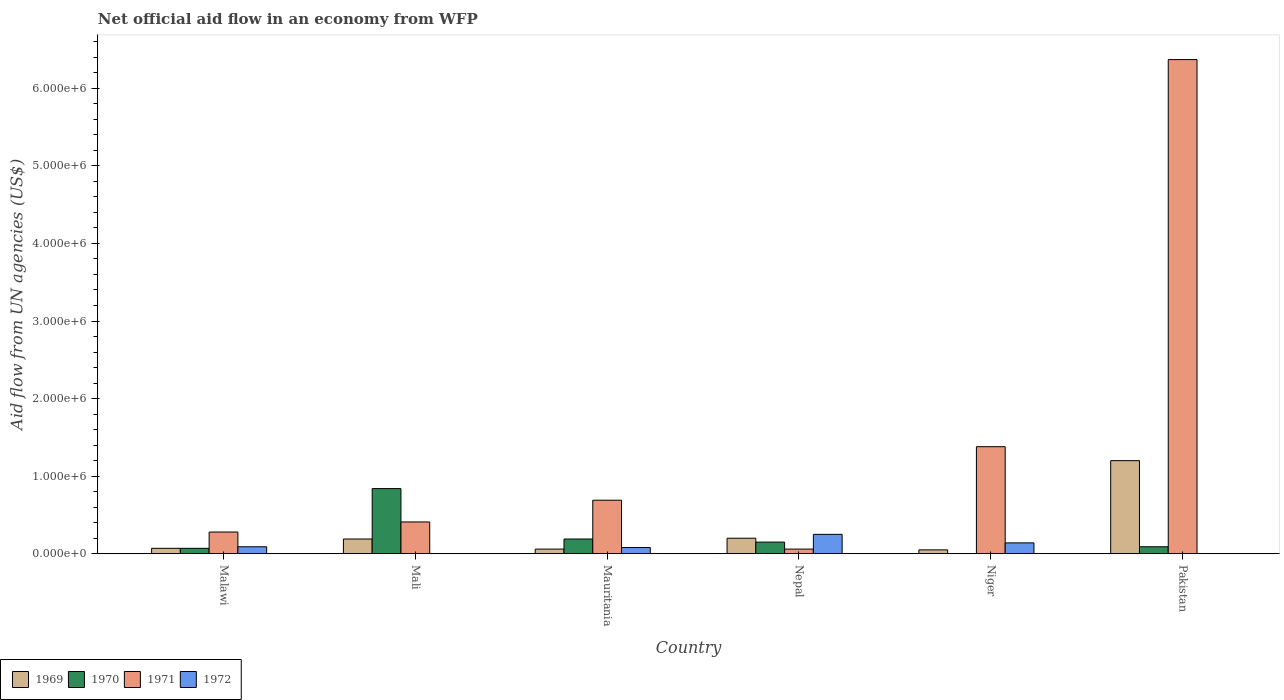How many different coloured bars are there?
Provide a short and direct response. 4. Are the number of bars per tick equal to the number of legend labels?
Provide a short and direct response. No. How many bars are there on the 6th tick from the left?
Provide a short and direct response. 3. How many bars are there on the 3rd tick from the right?
Ensure brevity in your answer.  4. What is the label of the 4th group of bars from the left?
Your response must be concise. Nepal. In how many cases, is the number of bars for a given country not equal to the number of legend labels?
Ensure brevity in your answer.  3. Across all countries, what is the maximum net official aid flow in 1971?
Your answer should be compact. 6.37e+06. Across all countries, what is the minimum net official aid flow in 1969?
Make the answer very short. 5.00e+04. In which country was the net official aid flow in 1970 maximum?
Your answer should be very brief. Mali. What is the total net official aid flow in 1969 in the graph?
Give a very brief answer. 1.77e+06. What is the difference between the net official aid flow in 1971 in Mali and that in Nepal?
Make the answer very short. 3.50e+05. What is the difference between the net official aid flow in 1969 in Pakistan and the net official aid flow in 1971 in Niger?
Your response must be concise. -1.80e+05. What is the average net official aid flow in 1970 per country?
Offer a terse response. 2.23e+05. What is the ratio of the net official aid flow in 1972 in Nepal to that in Niger?
Offer a terse response. 1.79. What is the difference between the highest and the second highest net official aid flow in 1971?
Offer a terse response. 5.68e+06. What is the difference between the highest and the lowest net official aid flow in 1971?
Your response must be concise. 6.31e+06. In how many countries, is the net official aid flow in 1969 greater than the average net official aid flow in 1969 taken over all countries?
Your response must be concise. 1. Is the sum of the net official aid flow in 1969 in Malawi and Mauritania greater than the maximum net official aid flow in 1970 across all countries?
Your answer should be compact. No. Is it the case that in every country, the sum of the net official aid flow in 1970 and net official aid flow in 1971 is greater than the net official aid flow in 1969?
Make the answer very short. Yes. Are all the bars in the graph horizontal?
Your answer should be very brief. No. How many countries are there in the graph?
Keep it short and to the point. 6. What is the difference between two consecutive major ticks on the Y-axis?
Provide a short and direct response. 1.00e+06. Are the values on the major ticks of Y-axis written in scientific E-notation?
Your response must be concise. Yes. Does the graph contain grids?
Your answer should be compact. No. Where does the legend appear in the graph?
Offer a terse response. Bottom left. How many legend labels are there?
Your answer should be very brief. 4. What is the title of the graph?
Offer a very short reply. Net official aid flow in an economy from WFP. What is the label or title of the Y-axis?
Offer a terse response. Aid flow from UN agencies (US$). What is the Aid flow from UN agencies (US$) of 1969 in Malawi?
Offer a very short reply. 7.00e+04. What is the Aid flow from UN agencies (US$) of 1970 in Malawi?
Offer a terse response. 7.00e+04. What is the Aid flow from UN agencies (US$) of 1970 in Mali?
Your answer should be compact. 8.40e+05. What is the Aid flow from UN agencies (US$) in 1971 in Mali?
Provide a succinct answer. 4.10e+05. What is the Aid flow from UN agencies (US$) of 1969 in Mauritania?
Provide a short and direct response. 6.00e+04. What is the Aid flow from UN agencies (US$) of 1971 in Mauritania?
Keep it short and to the point. 6.90e+05. What is the Aid flow from UN agencies (US$) in 1972 in Mauritania?
Keep it short and to the point. 8.00e+04. What is the Aid flow from UN agencies (US$) of 1969 in Nepal?
Offer a terse response. 2.00e+05. What is the Aid flow from UN agencies (US$) in 1970 in Nepal?
Provide a succinct answer. 1.50e+05. What is the Aid flow from UN agencies (US$) in 1969 in Niger?
Give a very brief answer. 5.00e+04. What is the Aid flow from UN agencies (US$) of 1970 in Niger?
Give a very brief answer. 0. What is the Aid flow from UN agencies (US$) in 1971 in Niger?
Your answer should be very brief. 1.38e+06. What is the Aid flow from UN agencies (US$) of 1969 in Pakistan?
Your response must be concise. 1.20e+06. What is the Aid flow from UN agencies (US$) of 1971 in Pakistan?
Make the answer very short. 6.37e+06. What is the Aid flow from UN agencies (US$) in 1972 in Pakistan?
Provide a short and direct response. 0. Across all countries, what is the maximum Aid flow from UN agencies (US$) in 1969?
Your answer should be very brief. 1.20e+06. Across all countries, what is the maximum Aid flow from UN agencies (US$) of 1970?
Make the answer very short. 8.40e+05. Across all countries, what is the maximum Aid flow from UN agencies (US$) in 1971?
Your answer should be compact. 6.37e+06. Across all countries, what is the minimum Aid flow from UN agencies (US$) in 1970?
Offer a very short reply. 0. Across all countries, what is the minimum Aid flow from UN agencies (US$) of 1972?
Ensure brevity in your answer.  0. What is the total Aid flow from UN agencies (US$) in 1969 in the graph?
Give a very brief answer. 1.77e+06. What is the total Aid flow from UN agencies (US$) of 1970 in the graph?
Offer a terse response. 1.34e+06. What is the total Aid flow from UN agencies (US$) of 1971 in the graph?
Make the answer very short. 9.19e+06. What is the total Aid flow from UN agencies (US$) of 1972 in the graph?
Make the answer very short. 5.60e+05. What is the difference between the Aid flow from UN agencies (US$) of 1969 in Malawi and that in Mali?
Offer a terse response. -1.20e+05. What is the difference between the Aid flow from UN agencies (US$) of 1970 in Malawi and that in Mali?
Make the answer very short. -7.70e+05. What is the difference between the Aid flow from UN agencies (US$) of 1971 in Malawi and that in Mali?
Offer a very short reply. -1.30e+05. What is the difference between the Aid flow from UN agencies (US$) of 1969 in Malawi and that in Mauritania?
Provide a short and direct response. 10000. What is the difference between the Aid flow from UN agencies (US$) of 1971 in Malawi and that in Mauritania?
Provide a succinct answer. -4.10e+05. What is the difference between the Aid flow from UN agencies (US$) of 1972 in Malawi and that in Mauritania?
Give a very brief answer. 10000. What is the difference between the Aid flow from UN agencies (US$) of 1971 in Malawi and that in Niger?
Provide a short and direct response. -1.10e+06. What is the difference between the Aid flow from UN agencies (US$) of 1972 in Malawi and that in Niger?
Keep it short and to the point. -5.00e+04. What is the difference between the Aid flow from UN agencies (US$) in 1969 in Malawi and that in Pakistan?
Your answer should be compact. -1.13e+06. What is the difference between the Aid flow from UN agencies (US$) in 1971 in Malawi and that in Pakistan?
Make the answer very short. -6.09e+06. What is the difference between the Aid flow from UN agencies (US$) of 1969 in Mali and that in Mauritania?
Your answer should be very brief. 1.30e+05. What is the difference between the Aid flow from UN agencies (US$) of 1970 in Mali and that in Mauritania?
Offer a very short reply. 6.50e+05. What is the difference between the Aid flow from UN agencies (US$) of 1971 in Mali and that in Mauritania?
Keep it short and to the point. -2.80e+05. What is the difference between the Aid flow from UN agencies (US$) of 1970 in Mali and that in Nepal?
Give a very brief answer. 6.90e+05. What is the difference between the Aid flow from UN agencies (US$) of 1971 in Mali and that in Nepal?
Provide a short and direct response. 3.50e+05. What is the difference between the Aid flow from UN agencies (US$) of 1969 in Mali and that in Niger?
Provide a short and direct response. 1.40e+05. What is the difference between the Aid flow from UN agencies (US$) of 1971 in Mali and that in Niger?
Provide a short and direct response. -9.70e+05. What is the difference between the Aid flow from UN agencies (US$) of 1969 in Mali and that in Pakistan?
Your answer should be compact. -1.01e+06. What is the difference between the Aid flow from UN agencies (US$) of 1970 in Mali and that in Pakistan?
Keep it short and to the point. 7.50e+05. What is the difference between the Aid flow from UN agencies (US$) in 1971 in Mali and that in Pakistan?
Your answer should be very brief. -5.96e+06. What is the difference between the Aid flow from UN agencies (US$) of 1969 in Mauritania and that in Nepal?
Your answer should be very brief. -1.40e+05. What is the difference between the Aid flow from UN agencies (US$) of 1970 in Mauritania and that in Nepal?
Offer a terse response. 4.00e+04. What is the difference between the Aid flow from UN agencies (US$) in 1971 in Mauritania and that in Nepal?
Your answer should be compact. 6.30e+05. What is the difference between the Aid flow from UN agencies (US$) of 1972 in Mauritania and that in Nepal?
Offer a terse response. -1.70e+05. What is the difference between the Aid flow from UN agencies (US$) in 1969 in Mauritania and that in Niger?
Your response must be concise. 10000. What is the difference between the Aid flow from UN agencies (US$) of 1971 in Mauritania and that in Niger?
Make the answer very short. -6.90e+05. What is the difference between the Aid flow from UN agencies (US$) in 1969 in Mauritania and that in Pakistan?
Your answer should be very brief. -1.14e+06. What is the difference between the Aid flow from UN agencies (US$) in 1970 in Mauritania and that in Pakistan?
Give a very brief answer. 1.00e+05. What is the difference between the Aid flow from UN agencies (US$) of 1971 in Mauritania and that in Pakistan?
Your response must be concise. -5.68e+06. What is the difference between the Aid flow from UN agencies (US$) in 1971 in Nepal and that in Niger?
Your answer should be very brief. -1.32e+06. What is the difference between the Aid flow from UN agencies (US$) of 1972 in Nepal and that in Niger?
Provide a succinct answer. 1.10e+05. What is the difference between the Aid flow from UN agencies (US$) in 1969 in Nepal and that in Pakistan?
Your answer should be very brief. -1.00e+06. What is the difference between the Aid flow from UN agencies (US$) in 1971 in Nepal and that in Pakistan?
Offer a very short reply. -6.31e+06. What is the difference between the Aid flow from UN agencies (US$) in 1969 in Niger and that in Pakistan?
Offer a terse response. -1.15e+06. What is the difference between the Aid flow from UN agencies (US$) of 1971 in Niger and that in Pakistan?
Offer a very short reply. -4.99e+06. What is the difference between the Aid flow from UN agencies (US$) in 1969 in Malawi and the Aid flow from UN agencies (US$) in 1970 in Mali?
Your answer should be very brief. -7.70e+05. What is the difference between the Aid flow from UN agencies (US$) of 1969 in Malawi and the Aid flow from UN agencies (US$) of 1971 in Mali?
Keep it short and to the point. -3.40e+05. What is the difference between the Aid flow from UN agencies (US$) in 1970 in Malawi and the Aid flow from UN agencies (US$) in 1971 in Mali?
Make the answer very short. -3.40e+05. What is the difference between the Aid flow from UN agencies (US$) of 1969 in Malawi and the Aid flow from UN agencies (US$) of 1970 in Mauritania?
Your answer should be very brief. -1.20e+05. What is the difference between the Aid flow from UN agencies (US$) of 1969 in Malawi and the Aid flow from UN agencies (US$) of 1971 in Mauritania?
Your response must be concise. -6.20e+05. What is the difference between the Aid flow from UN agencies (US$) of 1969 in Malawi and the Aid flow from UN agencies (US$) of 1972 in Mauritania?
Your answer should be very brief. -10000. What is the difference between the Aid flow from UN agencies (US$) of 1970 in Malawi and the Aid flow from UN agencies (US$) of 1971 in Mauritania?
Your answer should be compact. -6.20e+05. What is the difference between the Aid flow from UN agencies (US$) of 1971 in Malawi and the Aid flow from UN agencies (US$) of 1972 in Mauritania?
Offer a very short reply. 2.00e+05. What is the difference between the Aid flow from UN agencies (US$) of 1969 in Malawi and the Aid flow from UN agencies (US$) of 1970 in Nepal?
Provide a succinct answer. -8.00e+04. What is the difference between the Aid flow from UN agencies (US$) in 1969 in Malawi and the Aid flow from UN agencies (US$) in 1971 in Nepal?
Offer a terse response. 10000. What is the difference between the Aid flow from UN agencies (US$) of 1969 in Malawi and the Aid flow from UN agencies (US$) of 1972 in Nepal?
Ensure brevity in your answer.  -1.80e+05. What is the difference between the Aid flow from UN agencies (US$) of 1969 in Malawi and the Aid flow from UN agencies (US$) of 1971 in Niger?
Ensure brevity in your answer.  -1.31e+06. What is the difference between the Aid flow from UN agencies (US$) of 1970 in Malawi and the Aid flow from UN agencies (US$) of 1971 in Niger?
Give a very brief answer. -1.31e+06. What is the difference between the Aid flow from UN agencies (US$) in 1970 in Malawi and the Aid flow from UN agencies (US$) in 1972 in Niger?
Your response must be concise. -7.00e+04. What is the difference between the Aid flow from UN agencies (US$) of 1971 in Malawi and the Aid flow from UN agencies (US$) of 1972 in Niger?
Offer a very short reply. 1.40e+05. What is the difference between the Aid flow from UN agencies (US$) in 1969 in Malawi and the Aid flow from UN agencies (US$) in 1970 in Pakistan?
Keep it short and to the point. -2.00e+04. What is the difference between the Aid flow from UN agencies (US$) of 1969 in Malawi and the Aid flow from UN agencies (US$) of 1971 in Pakistan?
Give a very brief answer. -6.30e+06. What is the difference between the Aid flow from UN agencies (US$) in 1970 in Malawi and the Aid flow from UN agencies (US$) in 1971 in Pakistan?
Offer a very short reply. -6.30e+06. What is the difference between the Aid flow from UN agencies (US$) in 1969 in Mali and the Aid flow from UN agencies (US$) in 1970 in Mauritania?
Give a very brief answer. 0. What is the difference between the Aid flow from UN agencies (US$) in 1969 in Mali and the Aid flow from UN agencies (US$) in 1971 in Mauritania?
Your response must be concise. -5.00e+05. What is the difference between the Aid flow from UN agencies (US$) of 1970 in Mali and the Aid flow from UN agencies (US$) of 1971 in Mauritania?
Keep it short and to the point. 1.50e+05. What is the difference between the Aid flow from UN agencies (US$) of 1970 in Mali and the Aid flow from UN agencies (US$) of 1972 in Mauritania?
Your answer should be compact. 7.60e+05. What is the difference between the Aid flow from UN agencies (US$) of 1971 in Mali and the Aid flow from UN agencies (US$) of 1972 in Mauritania?
Keep it short and to the point. 3.30e+05. What is the difference between the Aid flow from UN agencies (US$) in 1969 in Mali and the Aid flow from UN agencies (US$) in 1971 in Nepal?
Offer a very short reply. 1.30e+05. What is the difference between the Aid flow from UN agencies (US$) in 1969 in Mali and the Aid flow from UN agencies (US$) in 1972 in Nepal?
Your answer should be very brief. -6.00e+04. What is the difference between the Aid flow from UN agencies (US$) of 1970 in Mali and the Aid flow from UN agencies (US$) of 1971 in Nepal?
Your response must be concise. 7.80e+05. What is the difference between the Aid flow from UN agencies (US$) of 1970 in Mali and the Aid flow from UN agencies (US$) of 1972 in Nepal?
Your response must be concise. 5.90e+05. What is the difference between the Aid flow from UN agencies (US$) in 1971 in Mali and the Aid flow from UN agencies (US$) in 1972 in Nepal?
Your response must be concise. 1.60e+05. What is the difference between the Aid flow from UN agencies (US$) of 1969 in Mali and the Aid flow from UN agencies (US$) of 1971 in Niger?
Give a very brief answer. -1.19e+06. What is the difference between the Aid flow from UN agencies (US$) of 1969 in Mali and the Aid flow from UN agencies (US$) of 1972 in Niger?
Make the answer very short. 5.00e+04. What is the difference between the Aid flow from UN agencies (US$) of 1970 in Mali and the Aid flow from UN agencies (US$) of 1971 in Niger?
Your response must be concise. -5.40e+05. What is the difference between the Aid flow from UN agencies (US$) in 1970 in Mali and the Aid flow from UN agencies (US$) in 1972 in Niger?
Make the answer very short. 7.00e+05. What is the difference between the Aid flow from UN agencies (US$) in 1969 in Mali and the Aid flow from UN agencies (US$) in 1970 in Pakistan?
Give a very brief answer. 1.00e+05. What is the difference between the Aid flow from UN agencies (US$) of 1969 in Mali and the Aid flow from UN agencies (US$) of 1971 in Pakistan?
Provide a succinct answer. -6.18e+06. What is the difference between the Aid flow from UN agencies (US$) in 1970 in Mali and the Aid flow from UN agencies (US$) in 1971 in Pakistan?
Offer a terse response. -5.53e+06. What is the difference between the Aid flow from UN agencies (US$) of 1970 in Mauritania and the Aid flow from UN agencies (US$) of 1971 in Nepal?
Make the answer very short. 1.30e+05. What is the difference between the Aid flow from UN agencies (US$) of 1971 in Mauritania and the Aid flow from UN agencies (US$) of 1972 in Nepal?
Your answer should be very brief. 4.40e+05. What is the difference between the Aid flow from UN agencies (US$) in 1969 in Mauritania and the Aid flow from UN agencies (US$) in 1971 in Niger?
Provide a short and direct response. -1.32e+06. What is the difference between the Aid flow from UN agencies (US$) of 1970 in Mauritania and the Aid flow from UN agencies (US$) of 1971 in Niger?
Ensure brevity in your answer.  -1.19e+06. What is the difference between the Aid flow from UN agencies (US$) of 1970 in Mauritania and the Aid flow from UN agencies (US$) of 1972 in Niger?
Your answer should be compact. 5.00e+04. What is the difference between the Aid flow from UN agencies (US$) in 1971 in Mauritania and the Aid flow from UN agencies (US$) in 1972 in Niger?
Provide a short and direct response. 5.50e+05. What is the difference between the Aid flow from UN agencies (US$) of 1969 in Mauritania and the Aid flow from UN agencies (US$) of 1971 in Pakistan?
Provide a short and direct response. -6.31e+06. What is the difference between the Aid flow from UN agencies (US$) in 1970 in Mauritania and the Aid flow from UN agencies (US$) in 1971 in Pakistan?
Provide a short and direct response. -6.18e+06. What is the difference between the Aid flow from UN agencies (US$) in 1969 in Nepal and the Aid flow from UN agencies (US$) in 1971 in Niger?
Provide a short and direct response. -1.18e+06. What is the difference between the Aid flow from UN agencies (US$) in 1969 in Nepal and the Aid flow from UN agencies (US$) in 1972 in Niger?
Keep it short and to the point. 6.00e+04. What is the difference between the Aid flow from UN agencies (US$) of 1970 in Nepal and the Aid flow from UN agencies (US$) of 1971 in Niger?
Give a very brief answer. -1.23e+06. What is the difference between the Aid flow from UN agencies (US$) in 1971 in Nepal and the Aid flow from UN agencies (US$) in 1972 in Niger?
Your answer should be compact. -8.00e+04. What is the difference between the Aid flow from UN agencies (US$) of 1969 in Nepal and the Aid flow from UN agencies (US$) of 1970 in Pakistan?
Provide a succinct answer. 1.10e+05. What is the difference between the Aid flow from UN agencies (US$) of 1969 in Nepal and the Aid flow from UN agencies (US$) of 1971 in Pakistan?
Offer a very short reply. -6.17e+06. What is the difference between the Aid flow from UN agencies (US$) in 1970 in Nepal and the Aid flow from UN agencies (US$) in 1971 in Pakistan?
Your answer should be compact. -6.22e+06. What is the difference between the Aid flow from UN agencies (US$) in 1969 in Niger and the Aid flow from UN agencies (US$) in 1970 in Pakistan?
Give a very brief answer. -4.00e+04. What is the difference between the Aid flow from UN agencies (US$) in 1969 in Niger and the Aid flow from UN agencies (US$) in 1971 in Pakistan?
Offer a very short reply. -6.32e+06. What is the average Aid flow from UN agencies (US$) in 1969 per country?
Make the answer very short. 2.95e+05. What is the average Aid flow from UN agencies (US$) in 1970 per country?
Offer a very short reply. 2.23e+05. What is the average Aid flow from UN agencies (US$) of 1971 per country?
Offer a very short reply. 1.53e+06. What is the average Aid flow from UN agencies (US$) in 1972 per country?
Your response must be concise. 9.33e+04. What is the difference between the Aid flow from UN agencies (US$) of 1969 and Aid flow from UN agencies (US$) of 1972 in Malawi?
Your response must be concise. -2.00e+04. What is the difference between the Aid flow from UN agencies (US$) in 1970 and Aid flow from UN agencies (US$) in 1971 in Malawi?
Keep it short and to the point. -2.10e+05. What is the difference between the Aid flow from UN agencies (US$) in 1970 and Aid flow from UN agencies (US$) in 1972 in Malawi?
Your response must be concise. -2.00e+04. What is the difference between the Aid flow from UN agencies (US$) of 1969 and Aid flow from UN agencies (US$) of 1970 in Mali?
Keep it short and to the point. -6.50e+05. What is the difference between the Aid flow from UN agencies (US$) in 1969 and Aid flow from UN agencies (US$) in 1971 in Mali?
Provide a short and direct response. -2.20e+05. What is the difference between the Aid flow from UN agencies (US$) of 1970 and Aid flow from UN agencies (US$) of 1971 in Mali?
Keep it short and to the point. 4.30e+05. What is the difference between the Aid flow from UN agencies (US$) in 1969 and Aid flow from UN agencies (US$) in 1971 in Mauritania?
Make the answer very short. -6.30e+05. What is the difference between the Aid flow from UN agencies (US$) in 1970 and Aid flow from UN agencies (US$) in 1971 in Mauritania?
Ensure brevity in your answer.  -5.00e+05. What is the difference between the Aid flow from UN agencies (US$) in 1971 and Aid flow from UN agencies (US$) in 1972 in Mauritania?
Provide a short and direct response. 6.10e+05. What is the difference between the Aid flow from UN agencies (US$) of 1969 and Aid flow from UN agencies (US$) of 1972 in Nepal?
Offer a very short reply. -5.00e+04. What is the difference between the Aid flow from UN agencies (US$) of 1970 and Aid flow from UN agencies (US$) of 1971 in Nepal?
Offer a terse response. 9.00e+04. What is the difference between the Aid flow from UN agencies (US$) in 1970 and Aid flow from UN agencies (US$) in 1972 in Nepal?
Offer a terse response. -1.00e+05. What is the difference between the Aid flow from UN agencies (US$) in 1969 and Aid flow from UN agencies (US$) in 1971 in Niger?
Ensure brevity in your answer.  -1.33e+06. What is the difference between the Aid flow from UN agencies (US$) of 1971 and Aid flow from UN agencies (US$) of 1972 in Niger?
Give a very brief answer. 1.24e+06. What is the difference between the Aid flow from UN agencies (US$) in 1969 and Aid flow from UN agencies (US$) in 1970 in Pakistan?
Make the answer very short. 1.11e+06. What is the difference between the Aid flow from UN agencies (US$) in 1969 and Aid flow from UN agencies (US$) in 1971 in Pakistan?
Provide a short and direct response. -5.17e+06. What is the difference between the Aid flow from UN agencies (US$) in 1970 and Aid flow from UN agencies (US$) in 1971 in Pakistan?
Ensure brevity in your answer.  -6.28e+06. What is the ratio of the Aid flow from UN agencies (US$) of 1969 in Malawi to that in Mali?
Your response must be concise. 0.37. What is the ratio of the Aid flow from UN agencies (US$) of 1970 in Malawi to that in Mali?
Give a very brief answer. 0.08. What is the ratio of the Aid flow from UN agencies (US$) of 1971 in Malawi to that in Mali?
Ensure brevity in your answer.  0.68. What is the ratio of the Aid flow from UN agencies (US$) in 1969 in Malawi to that in Mauritania?
Offer a very short reply. 1.17. What is the ratio of the Aid flow from UN agencies (US$) in 1970 in Malawi to that in Mauritania?
Your answer should be very brief. 0.37. What is the ratio of the Aid flow from UN agencies (US$) of 1971 in Malawi to that in Mauritania?
Offer a very short reply. 0.41. What is the ratio of the Aid flow from UN agencies (US$) of 1972 in Malawi to that in Mauritania?
Offer a very short reply. 1.12. What is the ratio of the Aid flow from UN agencies (US$) in 1970 in Malawi to that in Nepal?
Your answer should be very brief. 0.47. What is the ratio of the Aid flow from UN agencies (US$) in 1971 in Malawi to that in Nepal?
Offer a very short reply. 4.67. What is the ratio of the Aid flow from UN agencies (US$) of 1972 in Malawi to that in Nepal?
Offer a terse response. 0.36. What is the ratio of the Aid flow from UN agencies (US$) of 1971 in Malawi to that in Niger?
Provide a succinct answer. 0.2. What is the ratio of the Aid flow from UN agencies (US$) in 1972 in Malawi to that in Niger?
Ensure brevity in your answer.  0.64. What is the ratio of the Aid flow from UN agencies (US$) of 1969 in Malawi to that in Pakistan?
Keep it short and to the point. 0.06. What is the ratio of the Aid flow from UN agencies (US$) in 1971 in Malawi to that in Pakistan?
Make the answer very short. 0.04. What is the ratio of the Aid flow from UN agencies (US$) of 1969 in Mali to that in Mauritania?
Make the answer very short. 3.17. What is the ratio of the Aid flow from UN agencies (US$) in 1970 in Mali to that in Mauritania?
Offer a very short reply. 4.42. What is the ratio of the Aid flow from UN agencies (US$) of 1971 in Mali to that in Mauritania?
Give a very brief answer. 0.59. What is the ratio of the Aid flow from UN agencies (US$) in 1971 in Mali to that in Nepal?
Offer a terse response. 6.83. What is the ratio of the Aid flow from UN agencies (US$) of 1971 in Mali to that in Niger?
Offer a very short reply. 0.3. What is the ratio of the Aid flow from UN agencies (US$) in 1969 in Mali to that in Pakistan?
Provide a succinct answer. 0.16. What is the ratio of the Aid flow from UN agencies (US$) in 1970 in Mali to that in Pakistan?
Your answer should be compact. 9.33. What is the ratio of the Aid flow from UN agencies (US$) in 1971 in Mali to that in Pakistan?
Provide a short and direct response. 0.06. What is the ratio of the Aid flow from UN agencies (US$) of 1969 in Mauritania to that in Nepal?
Provide a short and direct response. 0.3. What is the ratio of the Aid flow from UN agencies (US$) of 1970 in Mauritania to that in Nepal?
Offer a very short reply. 1.27. What is the ratio of the Aid flow from UN agencies (US$) in 1972 in Mauritania to that in Nepal?
Offer a very short reply. 0.32. What is the ratio of the Aid flow from UN agencies (US$) in 1969 in Mauritania to that in Niger?
Offer a very short reply. 1.2. What is the ratio of the Aid flow from UN agencies (US$) of 1972 in Mauritania to that in Niger?
Provide a short and direct response. 0.57. What is the ratio of the Aid flow from UN agencies (US$) of 1970 in Mauritania to that in Pakistan?
Give a very brief answer. 2.11. What is the ratio of the Aid flow from UN agencies (US$) in 1971 in Mauritania to that in Pakistan?
Give a very brief answer. 0.11. What is the ratio of the Aid flow from UN agencies (US$) of 1971 in Nepal to that in Niger?
Offer a very short reply. 0.04. What is the ratio of the Aid flow from UN agencies (US$) of 1972 in Nepal to that in Niger?
Keep it short and to the point. 1.79. What is the ratio of the Aid flow from UN agencies (US$) in 1969 in Nepal to that in Pakistan?
Give a very brief answer. 0.17. What is the ratio of the Aid flow from UN agencies (US$) in 1970 in Nepal to that in Pakistan?
Provide a succinct answer. 1.67. What is the ratio of the Aid flow from UN agencies (US$) of 1971 in Nepal to that in Pakistan?
Provide a succinct answer. 0.01. What is the ratio of the Aid flow from UN agencies (US$) in 1969 in Niger to that in Pakistan?
Provide a succinct answer. 0.04. What is the ratio of the Aid flow from UN agencies (US$) of 1971 in Niger to that in Pakistan?
Make the answer very short. 0.22. What is the difference between the highest and the second highest Aid flow from UN agencies (US$) of 1969?
Provide a succinct answer. 1.00e+06. What is the difference between the highest and the second highest Aid flow from UN agencies (US$) in 1970?
Make the answer very short. 6.50e+05. What is the difference between the highest and the second highest Aid flow from UN agencies (US$) of 1971?
Your answer should be very brief. 4.99e+06. What is the difference between the highest and the lowest Aid flow from UN agencies (US$) in 1969?
Provide a succinct answer. 1.15e+06. What is the difference between the highest and the lowest Aid flow from UN agencies (US$) of 1970?
Ensure brevity in your answer.  8.40e+05. What is the difference between the highest and the lowest Aid flow from UN agencies (US$) in 1971?
Your answer should be very brief. 6.31e+06. 